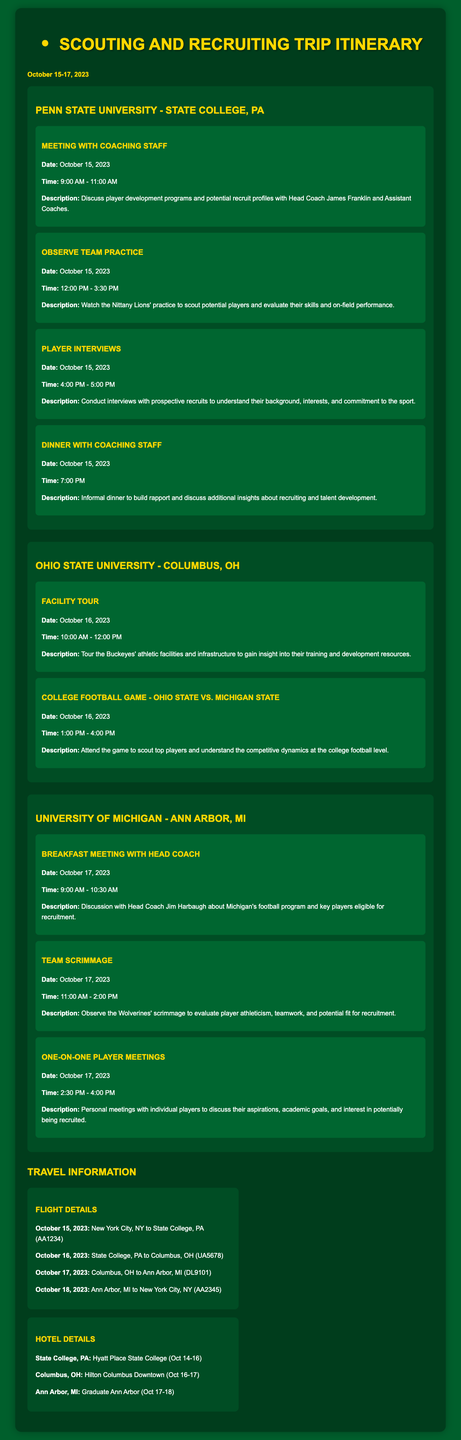What is the date of the scouting trip? The document specifies that the trip is from October 15-17, 2023.
Answer: October 15-17, 2023 Who is the head coach of Penn State University? The document mentions a meeting with Head Coach James Franklin during the trip.
Answer: James Franklin What time does the dinner with the coaching staff take place? According to the itinerary, dinner is scheduled for 7:00 PM on October 15, 2023.
Answer: 7:00 PM Which two teams play in the college football game on October 16? The document lists the matchup as Ohio State vs. Michigan State.
Answer: Ohio State vs. Michigan State What is the name of the hotel in Columbus, OH? The itinerary specifies Hilton Columbus Downtown as the hotel for the stay on October 16-17.
Answer: Hilton Columbus Downtown How long is the meeting with the coaching staff at Penn State? The meeting is scheduled for 2 hours, from 9:00 AM to 11:00 AM on October 15, 2023.
Answer: 2 hours What type of event is scheduled after the team scrimmage on October 17? The following event is the one-on-one player meetings scheduled for the same day.
Answer: One-on-One Player Meetings What is the first event scheduled on October 16? The first event listed for that day is the facility tour at Ohio State University.
Answer: Facility Tour 